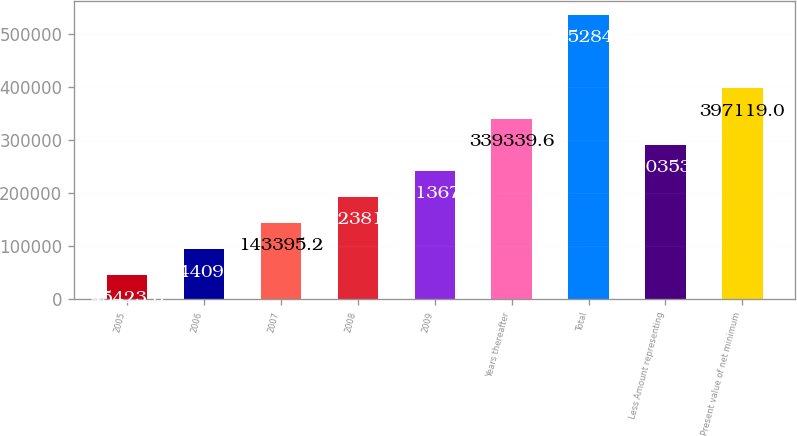Convert chart to OTSL. <chart><loc_0><loc_0><loc_500><loc_500><bar_chart><fcel>2005<fcel>2006<fcel>2007<fcel>2008<fcel>2009<fcel>Years thereafter<fcel>Total<fcel>Less Amount representing<fcel>Present value of net minimum<nl><fcel>45423<fcel>94409.1<fcel>143395<fcel>192381<fcel>241367<fcel>339340<fcel>535284<fcel>290354<fcel>397119<nl></chart> 